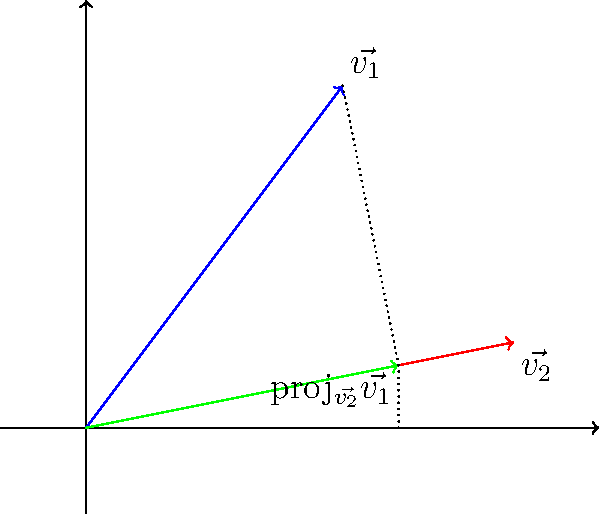In a legal case, two pieces of evidence are represented by vectors $\vec{v_1} = (3,4)$ and $\vec{v_2} = (5,1)$. The relevance of $\vec{v_1}$ to $\vec{v_2}$ is determined by the magnitude of the projection of $\vec{v_1}$ onto $\vec{v_2}$. Calculate the magnitude of this projection to assess the relevance of the evidence. To solve this problem, we'll follow these steps:

1) The formula for the projection of $\vec{v_1}$ onto $\vec{v_2}$ is:

   proj$_{\vec{v_2}}\vec{v_1} = \frac{\vec{v_1} \cdot \vec{v_2}}{\|\vec{v_2}\|^2} \vec{v_2}$

2) First, calculate the dot product $\vec{v_1} \cdot \vec{v_2}$:
   $\vec{v_1} \cdot \vec{v_2} = (3)(5) + (4)(1) = 15 + 4 = 19$

3) Calculate $\|\vec{v_2}\|^2$:
   $\|\vec{v_2}\|^2 = 5^2 + 1^2 = 25 + 1 = 26$

4) Now we can calculate the scalar projection:
   $\frac{\vec{v_1} \cdot \vec{v_2}}{\|\vec{v_2}\|^2} = \frac{19}{26}$

5) The vector projection would be:
   proj$_{\vec{v_2}}\vec{v_1} = \frac{19}{26}(5,1) = (\frac{95}{26}, \frac{19}{26})$

6) To find the magnitude of this projection, we calculate:
   $\|$proj$_{\vec{v_2}}\vec{v_1}\| = \sqrt{(\frac{95}{26})^2 + (\frac{19}{26})^2} = \frac{19}{26}\sqrt{26} \approx 3.6538$

This magnitude represents the relevance of the evidence $\vec{v_1}$ to $\vec{v_2}$.
Answer: $\frac{19}{26}\sqrt{26} \approx 3.6538$ 